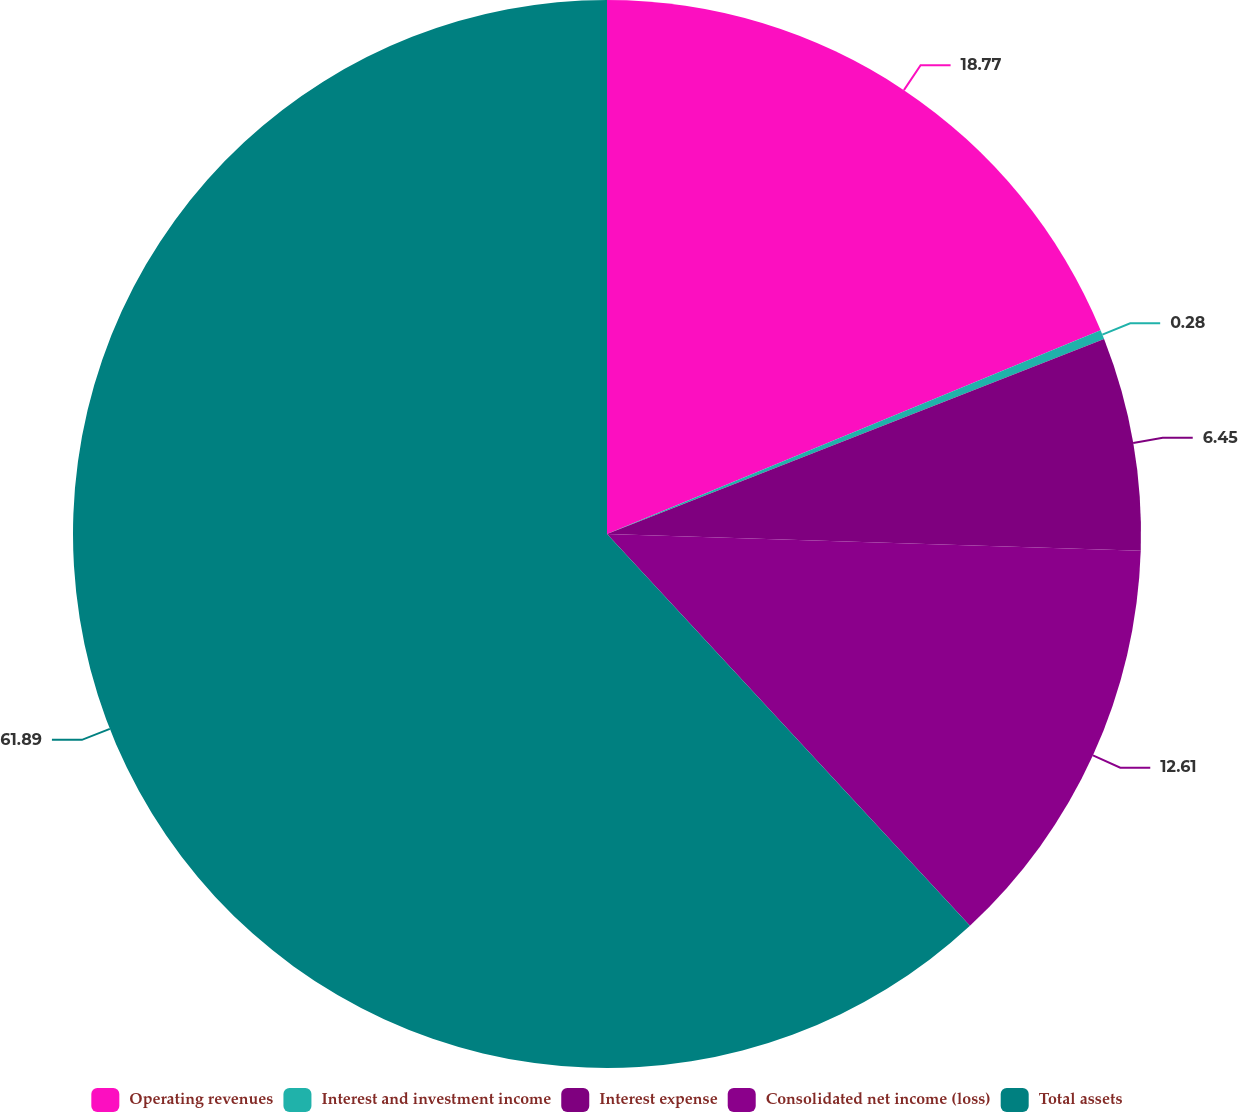Convert chart. <chart><loc_0><loc_0><loc_500><loc_500><pie_chart><fcel>Operating revenues<fcel>Interest and investment income<fcel>Interest expense<fcel>Consolidated net income (loss)<fcel>Total assets<nl><fcel>18.77%<fcel>0.28%<fcel>6.45%<fcel>12.61%<fcel>61.9%<nl></chart> 